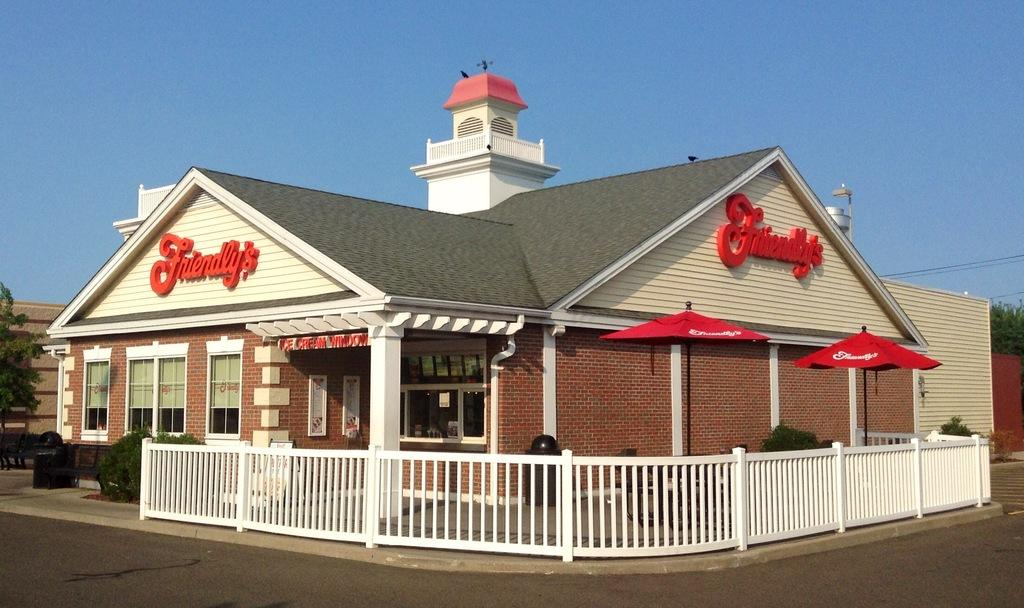Provide a one-sentence caption for the provided image. A restaurant named Friendlys along side another building. 